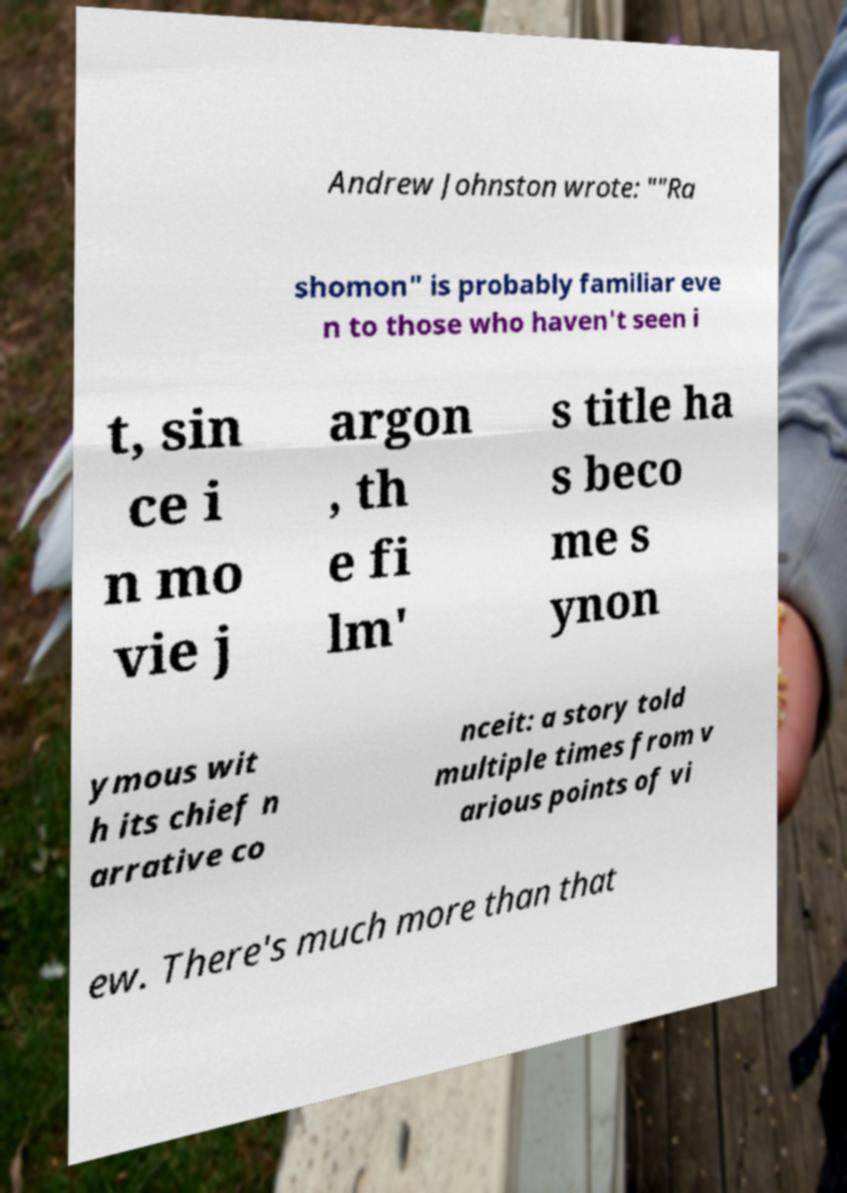Could you assist in decoding the text presented in this image and type it out clearly? Andrew Johnston wrote: ""Ra shomon" is probably familiar eve n to those who haven't seen i t, sin ce i n mo vie j argon , th e fi lm' s title ha s beco me s ynon ymous wit h its chief n arrative co nceit: a story told multiple times from v arious points of vi ew. There's much more than that 